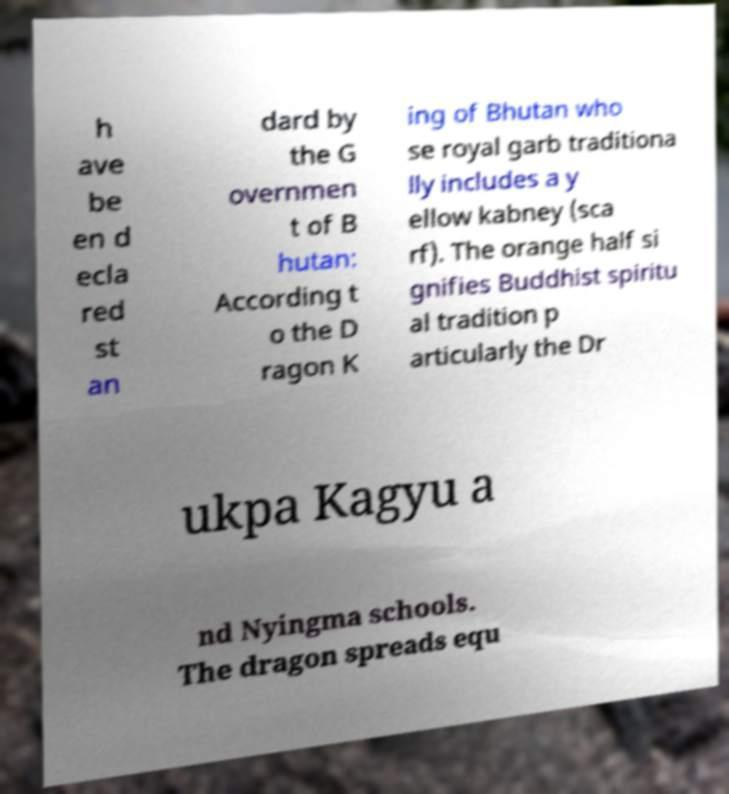There's text embedded in this image that I need extracted. Can you transcribe it verbatim? h ave be en d ecla red st an dard by the G overnmen t of B hutan: According t o the D ragon K ing of Bhutan who se royal garb traditiona lly includes a y ellow kabney (sca rf). The orange half si gnifies Buddhist spiritu al tradition p articularly the Dr ukpa Kagyu a nd Nyingma schools. The dragon spreads equ 